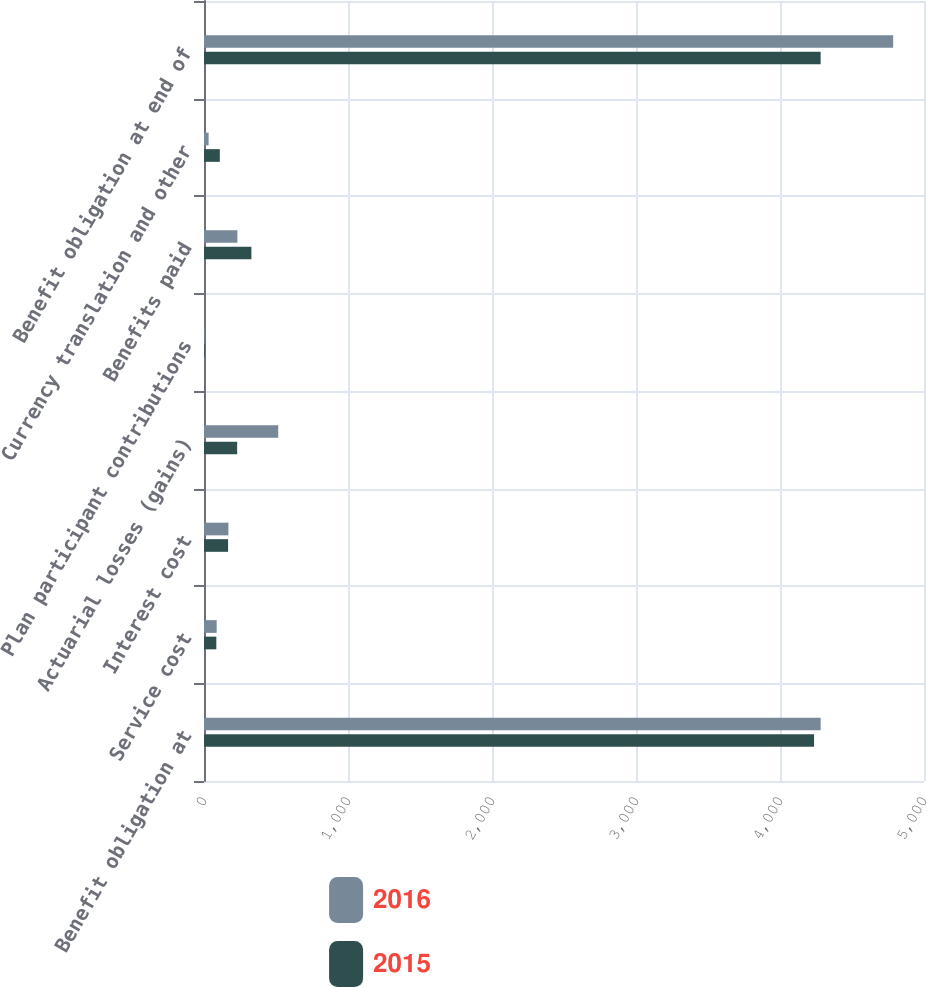Convert chart to OTSL. <chart><loc_0><loc_0><loc_500><loc_500><stacked_bar_chart><ecel><fcel>Benefit obligation at<fcel>Service cost<fcel>Interest cost<fcel>Actuarial losses (gains)<fcel>Plan participant contributions<fcel>Benefits paid<fcel>Currency translation and other<fcel>Benefit obligation at end of<nl><fcel>2016<fcel>4282.2<fcel>88<fcel>169.5<fcel>515.4<fcel>4.3<fcel>232<fcel>32<fcel>4785.9<nl><fcel>2015<fcel>4236.6<fcel>85.7<fcel>167.2<fcel>230.2<fcel>4.9<fcel>329.1<fcel>109.8<fcel>4282.2<nl></chart> 